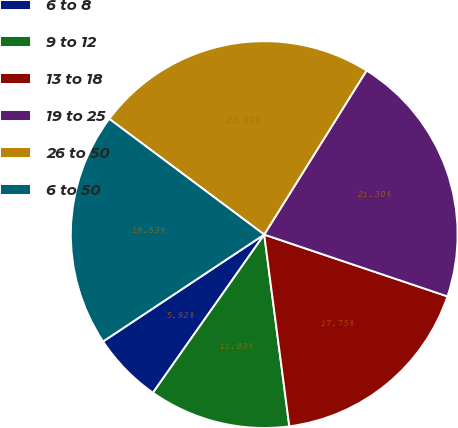Convert chart. <chart><loc_0><loc_0><loc_500><loc_500><pie_chart><fcel>6 to 8<fcel>9 to 12<fcel>13 to 18<fcel>19 to 25<fcel>26 to 50<fcel>6 to 50<nl><fcel>5.92%<fcel>11.83%<fcel>17.75%<fcel>21.3%<fcel>23.67%<fcel>19.53%<nl></chart> 